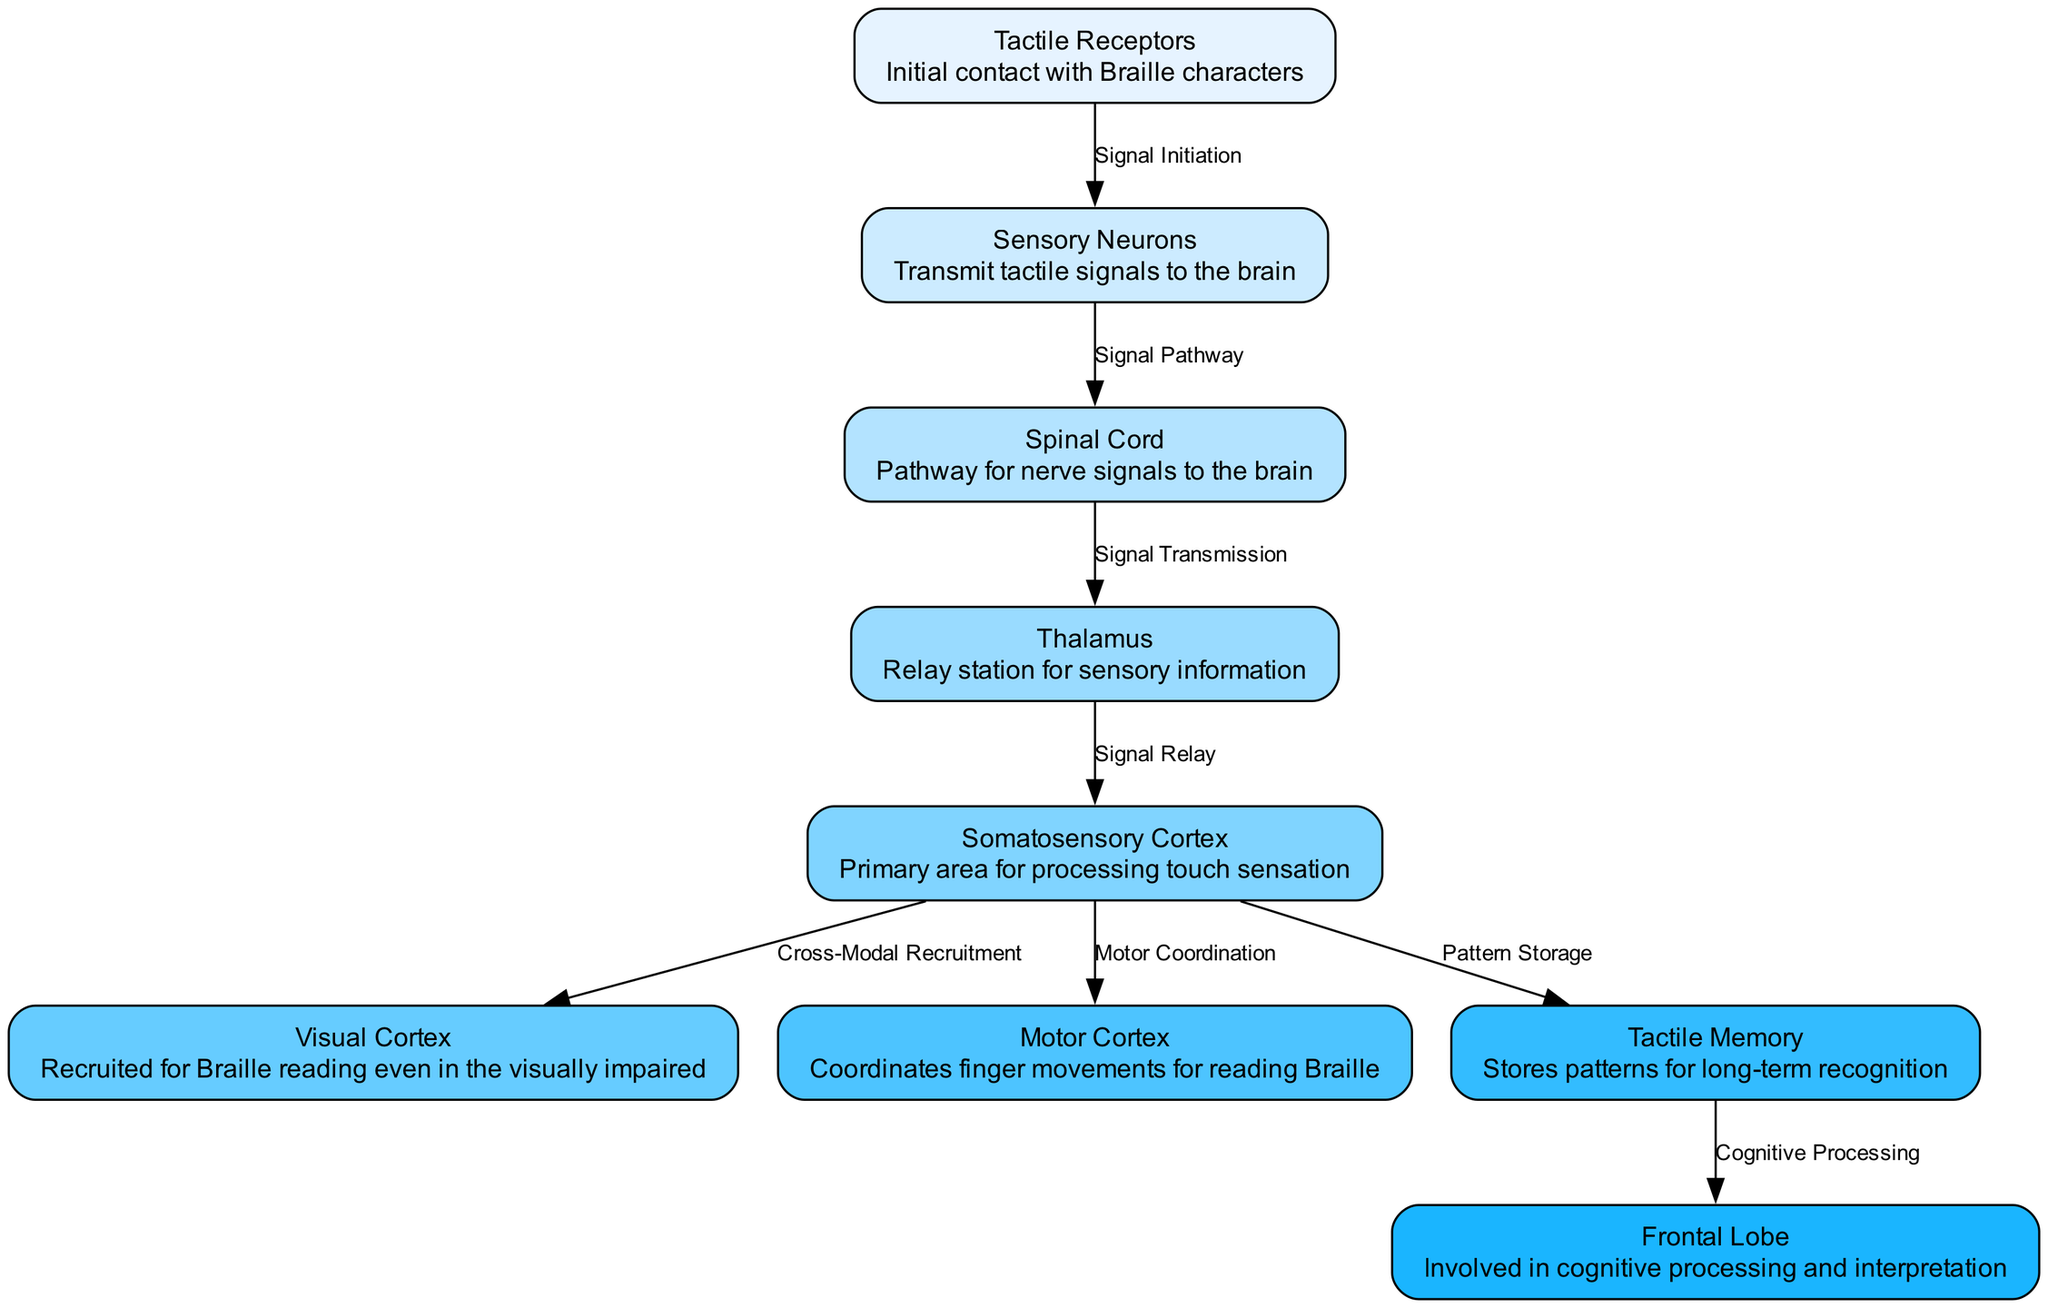What is the initial contact point for Braille characters? The initial contact point for Braille characters is defined as the "Tactile Receptors." This node is directly labeled in the diagram, representing the starting point of the Braille learning process.
Answer: Tactile Receptors How many nodes are present in the diagram? To find the number of nodes, we can simply count the distinct entries listed under the "nodes" section in the data. There are ten unique nodes mentioned in the diagram.
Answer: 10 What is the function of the Thalamus in this process? The Thalamus serves as a "Relay station for sensory information." This description is provided in the node of the Thalamus and is crucial for transmitting sensory signals onward to the somatosensory cortex.
Answer: Relay station for sensory information Which node is responsible for storing patterns for long-term recognition? The node responsible for storing patterns for long-term recognition is labeled "Tactile Memory." This node is integral to the retention of tactile patterns that one learns while reading Braille.
Answer: Tactile Memory What allows the Visual Cortex to be recruited for Braille reading? The diagram indicates "Cross-Modal Recruitment" as the connection between the somatosensory cortex and the visual cortex. This means that even individuals who are visually impaired can utilize their visual cortex for reading Braille due to sensory integration processes.
Answer: Cross-Modal Recruitment Describe the progression of signals from Tactile Receptors to Somatosensory Cortex. The signal begins at the Tactile Receptors, which initiates the signal (Signal Initiation). This signal is then transmitted through Sensory Neurons to the Spinal Cord (Signal Pathway), and from the Spinal Cord, it reaches the Thalamus (Signal Transmission). Finally, the Thalamus relays the signal to the Somatosensory Cortex (Signal Relay).
Answer: Tactile Receptors → Sensory Neurons → Spinal Cord → Thalamus → Somatosensory Cortex What role does the Motor Cortex play in the Braille learning process? The Motor Cortex is involved in "Motor Coordination," which is crucial for coordinating finger movements when reading Braille. This indicates that the Motor Cortex actively participates in the physical interaction with Braille characters during learning.
Answer: Motor Coordination Which part of the brain is involved in cognitive processing and interpretation? The "Frontal Lobe" is the part involved in cognitive processing and interpretation according to the diagram. This indicates that higher-level thinking about the tactile information learned is managed by the Frontal Lobe.
Answer: Frontal Lobe 